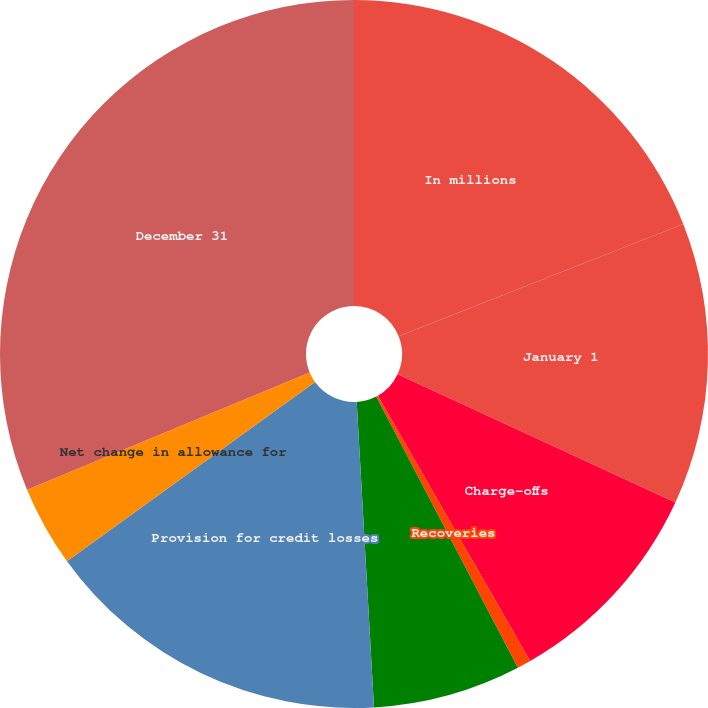<chart> <loc_0><loc_0><loc_500><loc_500><pie_chart><fcel>In millions<fcel>January 1<fcel>Charge-offs<fcel>Recoveries<fcel>Net charge-offs<fcel>Provision for credit losses<fcel>Net change in allowance for<fcel>December 31<nl><fcel>19.01%<fcel>12.88%<fcel>9.82%<fcel>0.63%<fcel>6.76%<fcel>15.95%<fcel>3.69%<fcel>31.26%<nl></chart> 